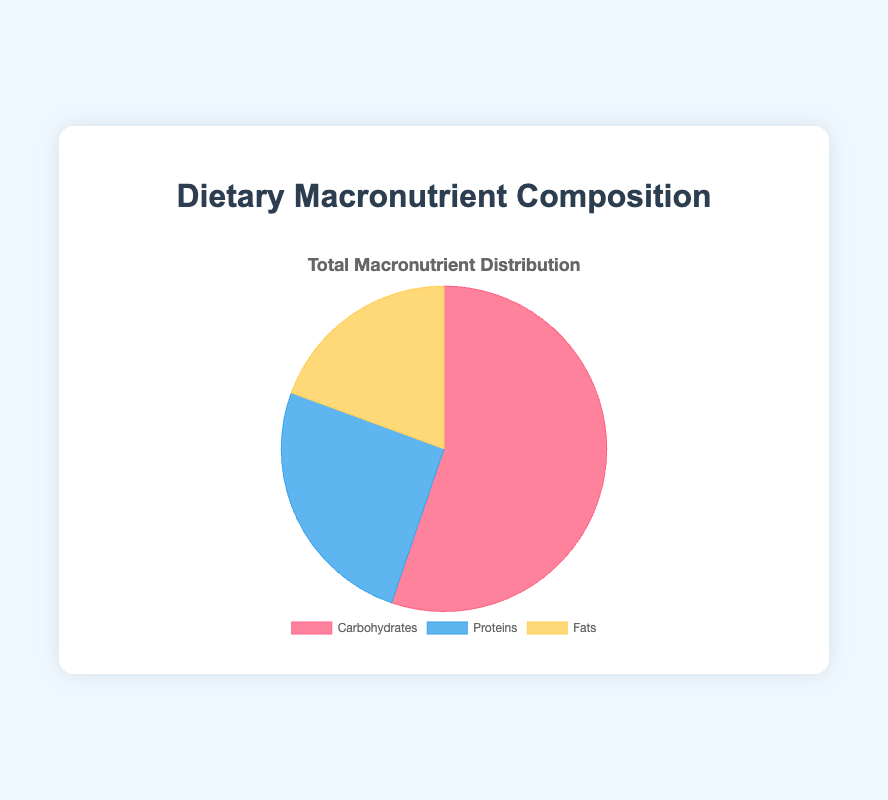What percentage of the total macronutrients are carbohydrates? The total amount of macronutrients is 185 (carbohydrates) + 85 (proteins) + 65 (fats) = 335. The percentage of carbohydrates is (185 / 335) * 100%.
Answer: 55.2% Which macronutrient has the smallest proportion in the chart? The chart's data shows that carbohydrates = 185, proteins = 85, and fats = 65. The smallest number is for fats.
Answer: Fats How do the proportions of proteins and fats compare? Proteins account for 85 units and fats account for 65 units. By comparing these values, proteins are greater than fats.
Answer: Proteins are greater than fats What is the sum of proteins and fats? The provided data indicates that the amount of proteins is 85, and the amount of fats is 65. Summing these values: 85 + 65 = 150.
Answer: 150 Which macronutrient is represented by the red section in the pie chart? In the pie chart, the red section represents carbohydrates, as indicated by the background color associated with the value of 185, which corresponds to the carbohydrates data point in the dataset.
Answer: Carbohydrates If the section for carbohydrates were split evenly into two parts, what amount would each part represent? Carbohydrates are 185 units. Dividing this amount by 2: 185 / 2 = 92.5 units.
Answer: 92.5 units Is there a meal with more proteins than fats in the dataset, and what is it? By reviewing the provided meal data, it can be observed that all meals have either an equal or higher amount of proteins compared to fats, except for Dinner. For Lunch, proteins = 30 and fats = 20, so Lunch has more proteins than fats.
Answer: Lunch What color represents the macronutrient with the middle value in the chart? The pie chart shows carbohydrates (185 in red), proteins (85 in blue), and fats (65 in yellow). The middle value is proteins, which are represented in blue.
Answer: Blue What is the ratio of carbohydrates to the sum of proteins and fats? The sum of proteins and fats is 85 (proteins) + 65 (fats) = 150. The ratio of carbohydrates to this sum is 185 / 150.
Answer: 1.23 Which macronutrient section takes up nearly one-fifth of the pie chart? Analyzing the total amount of macronutrients (335), one-fifth of this is approximately 67. The fats section, amounting to 65, is closest to this value and takes up nearly one-fifth of the pie chart.
Answer: Fats 